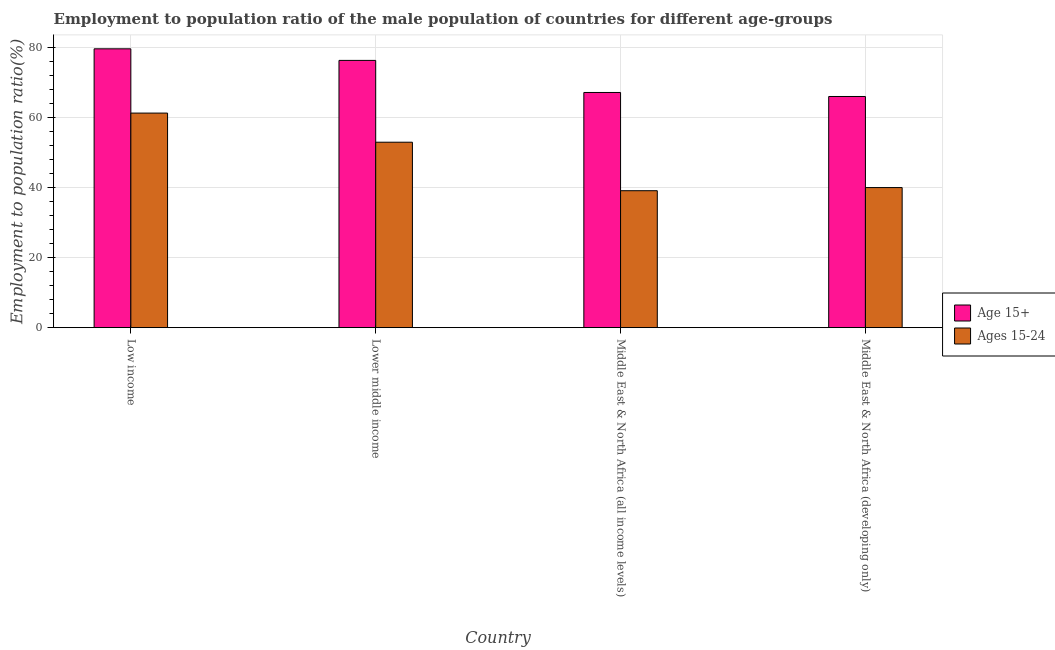How many different coloured bars are there?
Keep it short and to the point. 2. How many groups of bars are there?
Keep it short and to the point. 4. How many bars are there on the 3rd tick from the left?
Give a very brief answer. 2. How many bars are there on the 1st tick from the right?
Keep it short and to the point. 2. What is the label of the 3rd group of bars from the left?
Provide a short and direct response. Middle East & North Africa (all income levels). What is the employment to population ratio(age 15+) in Middle East & North Africa (developing only)?
Make the answer very short. 65.93. Across all countries, what is the maximum employment to population ratio(age 15-24)?
Make the answer very short. 61.2. Across all countries, what is the minimum employment to population ratio(age 15-24)?
Your response must be concise. 39.06. In which country was the employment to population ratio(age 15-24) minimum?
Ensure brevity in your answer.  Middle East & North Africa (all income levels). What is the total employment to population ratio(age 15+) in the graph?
Provide a succinct answer. 288.75. What is the difference between the employment to population ratio(age 15+) in Low income and that in Middle East & North Africa (developing only)?
Your answer should be very brief. 13.6. What is the difference between the employment to population ratio(age 15+) in Lower middle income and the employment to population ratio(age 15-24) in Low income?
Your response must be concise. 15.02. What is the average employment to population ratio(age 15-24) per country?
Keep it short and to the point. 48.27. What is the difference between the employment to population ratio(age 15+) and employment to population ratio(age 15-24) in Middle East & North Africa (all income levels)?
Offer a very short reply. 28.02. What is the ratio of the employment to population ratio(age 15+) in Low income to that in Middle East & North Africa (all income levels)?
Ensure brevity in your answer.  1.19. What is the difference between the highest and the second highest employment to population ratio(age 15+)?
Keep it short and to the point. 3.3. What is the difference between the highest and the lowest employment to population ratio(age 15-24)?
Keep it short and to the point. 22.14. In how many countries, is the employment to population ratio(age 15-24) greater than the average employment to population ratio(age 15-24) taken over all countries?
Make the answer very short. 2. Is the sum of the employment to population ratio(age 15-24) in Low income and Middle East & North Africa (all income levels) greater than the maximum employment to population ratio(age 15+) across all countries?
Your response must be concise. Yes. What does the 2nd bar from the left in Low income represents?
Ensure brevity in your answer.  Ages 15-24. What does the 1st bar from the right in Middle East & North Africa (developing only) represents?
Offer a terse response. Ages 15-24. How many bars are there?
Provide a succinct answer. 8. What is the difference between two consecutive major ticks on the Y-axis?
Your answer should be very brief. 20. Are the values on the major ticks of Y-axis written in scientific E-notation?
Your answer should be compact. No. Does the graph contain any zero values?
Keep it short and to the point. No. How are the legend labels stacked?
Your answer should be very brief. Vertical. What is the title of the graph?
Offer a very short reply. Employment to population ratio of the male population of countries for different age-groups. Does "Transport services" appear as one of the legend labels in the graph?
Provide a short and direct response. No. What is the Employment to population ratio(%) of Age 15+ in Low income?
Provide a succinct answer. 79.52. What is the Employment to population ratio(%) of Ages 15-24 in Low income?
Provide a short and direct response. 61.2. What is the Employment to population ratio(%) in Age 15+ in Lower middle income?
Give a very brief answer. 76.22. What is the Employment to population ratio(%) in Ages 15-24 in Lower middle income?
Your answer should be compact. 52.89. What is the Employment to population ratio(%) in Age 15+ in Middle East & North Africa (all income levels)?
Make the answer very short. 67.07. What is the Employment to population ratio(%) in Ages 15-24 in Middle East & North Africa (all income levels)?
Your response must be concise. 39.06. What is the Employment to population ratio(%) of Age 15+ in Middle East & North Africa (developing only)?
Provide a succinct answer. 65.93. What is the Employment to population ratio(%) of Ages 15-24 in Middle East & North Africa (developing only)?
Provide a succinct answer. 39.95. Across all countries, what is the maximum Employment to population ratio(%) of Age 15+?
Offer a terse response. 79.52. Across all countries, what is the maximum Employment to population ratio(%) of Ages 15-24?
Your answer should be compact. 61.2. Across all countries, what is the minimum Employment to population ratio(%) in Age 15+?
Make the answer very short. 65.93. Across all countries, what is the minimum Employment to population ratio(%) of Ages 15-24?
Make the answer very short. 39.06. What is the total Employment to population ratio(%) of Age 15+ in the graph?
Offer a very short reply. 288.75. What is the total Employment to population ratio(%) of Ages 15-24 in the graph?
Give a very brief answer. 193.1. What is the difference between the Employment to population ratio(%) of Age 15+ in Low income and that in Lower middle income?
Your response must be concise. 3.3. What is the difference between the Employment to population ratio(%) of Ages 15-24 in Low income and that in Lower middle income?
Provide a succinct answer. 8.31. What is the difference between the Employment to population ratio(%) in Age 15+ in Low income and that in Middle East & North Africa (all income levels)?
Offer a very short reply. 12.45. What is the difference between the Employment to population ratio(%) of Ages 15-24 in Low income and that in Middle East & North Africa (all income levels)?
Make the answer very short. 22.14. What is the difference between the Employment to population ratio(%) in Age 15+ in Low income and that in Middle East & North Africa (developing only)?
Your response must be concise. 13.6. What is the difference between the Employment to population ratio(%) in Ages 15-24 in Low income and that in Middle East & North Africa (developing only)?
Offer a terse response. 21.24. What is the difference between the Employment to population ratio(%) in Age 15+ in Lower middle income and that in Middle East & North Africa (all income levels)?
Give a very brief answer. 9.15. What is the difference between the Employment to population ratio(%) in Ages 15-24 in Lower middle income and that in Middle East & North Africa (all income levels)?
Offer a very short reply. 13.83. What is the difference between the Employment to population ratio(%) of Age 15+ in Lower middle income and that in Middle East & North Africa (developing only)?
Offer a terse response. 10.29. What is the difference between the Employment to population ratio(%) of Ages 15-24 in Lower middle income and that in Middle East & North Africa (developing only)?
Your answer should be very brief. 12.94. What is the difference between the Employment to population ratio(%) of Age 15+ in Middle East & North Africa (all income levels) and that in Middle East & North Africa (developing only)?
Your answer should be very brief. 1.14. What is the difference between the Employment to population ratio(%) of Ages 15-24 in Middle East & North Africa (all income levels) and that in Middle East & North Africa (developing only)?
Keep it short and to the point. -0.9. What is the difference between the Employment to population ratio(%) of Age 15+ in Low income and the Employment to population ratio(%) of Ages 15-24 in Lower middle income?
Your answer should be compact. 26.63. What is the difference between the Employment to population ratio(%) of Age 15+ in Low income and the Employment to population ratio(%) of Ages 15-24 in Middle East & North Africa (all income levels)?
Provide a succinct answer. 40.47. What is the difference between the Employment to population ratio(%) of Age 15+ in Low income and the Employment to population ratio(%) of Ages 15-24 in Middle East & North Africa (developing only)?
Give a very brief answer. 39.57. What is the difference between the Employment to population ratio(%) of Age 15+ in Lower middle income and the Employment to population ratio(%) of Ages 15-24 in Middle East & North Africa (all income levels)?
Offer a very short reply. 37.16. What is the difference between the Employment to population ratio(%) of Age 15+ in Lower middle income and the Employment to population ratio(%) of Ages 15-24 in Middle East & North Africa (developing only)?
Give a very brief answer. 36.27. What is the difference between the Employment to population ratio(%) of Age 15+ in Middle East & North Africa (all income levels) and the Employment to population ratio(%) of Ages 15-24 in Middle East & North Africa (developing only)?
Offer a very short reply. 27.12. What is the average Employment to population ratio(%) of Age 15+ per country?
Provide a short and direct response. 72.19. What is the average Employment to population ratio(%) of Ages 15-24 per country?
Your response must be concise. 48.27. What is the difference between the Employment to population ratio(%) in Age 15+ and Employment to population ratio(%) in Ages 15-24 in Low income?
Make the answer very short. 18.33. What is the difference between the Employment to population ratio(%) in Age 15+ and Employment to population ratio(%) in Ages 15-24 in Lower middle income?
Your response must be concise. 23.33. What is the difference between the Employment to population ratio(%) in Age 15+ and Employment to population ratio(%) in Ages 15-24 in Middle East & North Africa (all income levels)?
Provide a succinct answer. 28.02. What is the difference between the Employment to population ratio(%) of Age 15+ and Employment to population ratio(%) of Ages 15-24 in Middle East & North Africa (developing only)?
Provide a succinct answer. 25.98. What is the ratio of the Employment to population ratio(%) in Age 15+ in Low income to that in Lower middle income?
Provide a succinct answer. 1.04. What is the ratio of the Employment to population ratio(%) in Ages 15-24 in Low income to that in Lower middle income?
Provide a succinct answer. 1.16. What is the ratio of the Employment to population ratio(%) in Age 15+ in Low income to that in Middle East & North Africa (all income levels)?
Make the answer very short. 1.19. What is the ratio of the Employment to population ratio(%) of Ages 15-24 in Low income to that in Middle East & North Africa (all income levels)?
Your answer should be compact. 1.57. What is the ratio of the Employment to population ratio(%) of Age 15+ in Low income to that in Middle East & North Africa (developing only)?
Make the answer very short. 1.21. What is the ratio of the Employment to population ratio(%) of Ages 15-24 in Low income to that in Middle East & North Africa (developing only)?
Your answer should be very brief. 1.53. What is the ratio of the Employment to population ratio(%) of Age 15+ in Lower middle income to that in Middle East & North Africa (all income levels)?
Provide a short and direct response. 1.14. What is the ratio of the Employment to population ratio(%) in Ages 15-24 in Lower middle income to that in Middle East & North Africa (all income levels)?
Ensure brevity in your answer.  1.35. What is the ratio of the Employment to population ratio(%) in Age 15+ in Lower middle income to that in Middle East & North Africa (developing only)?
Provide a succinct answer. 1.16. What is the ratio of the Employment to population ratio(%) of Ages 15-24 in Lower middle income to that in Middle East & North Africa (developing only)?
Give a very brief answer. 1.32. What is the ratio of the Employment to population ratio(%) in Age 15+ in Middle East & North Africa (all income levels) to that in Middle East & North Africa (developing only)?
Offer a terse response. 1.02. What is the ratio of the Employment to population ratio(%) in Ages 15-24 in Middle East & North Africa (all income levels) to that in Middle East & North Africa (developing only)?
Give a very brief answer. 0.98. What is the difference between the highest and the second highest Employment to population ratio(%) of Age 15+?
Give a very brief answer. 3.3. What is the difference between the highest and the second highest Employment to population ratio(%) of Ages 15-24?
Provide a short and direct response. 8.31. What is the difference between the highest and the lowest Employment to population ratio(%) of Age 15+?
Provide a short and direct response. 13.6. What is the difference between the highest and the lowest Employment to population ratio(%) of Ages 15-24?
Your answer should be compact. 22.14. 